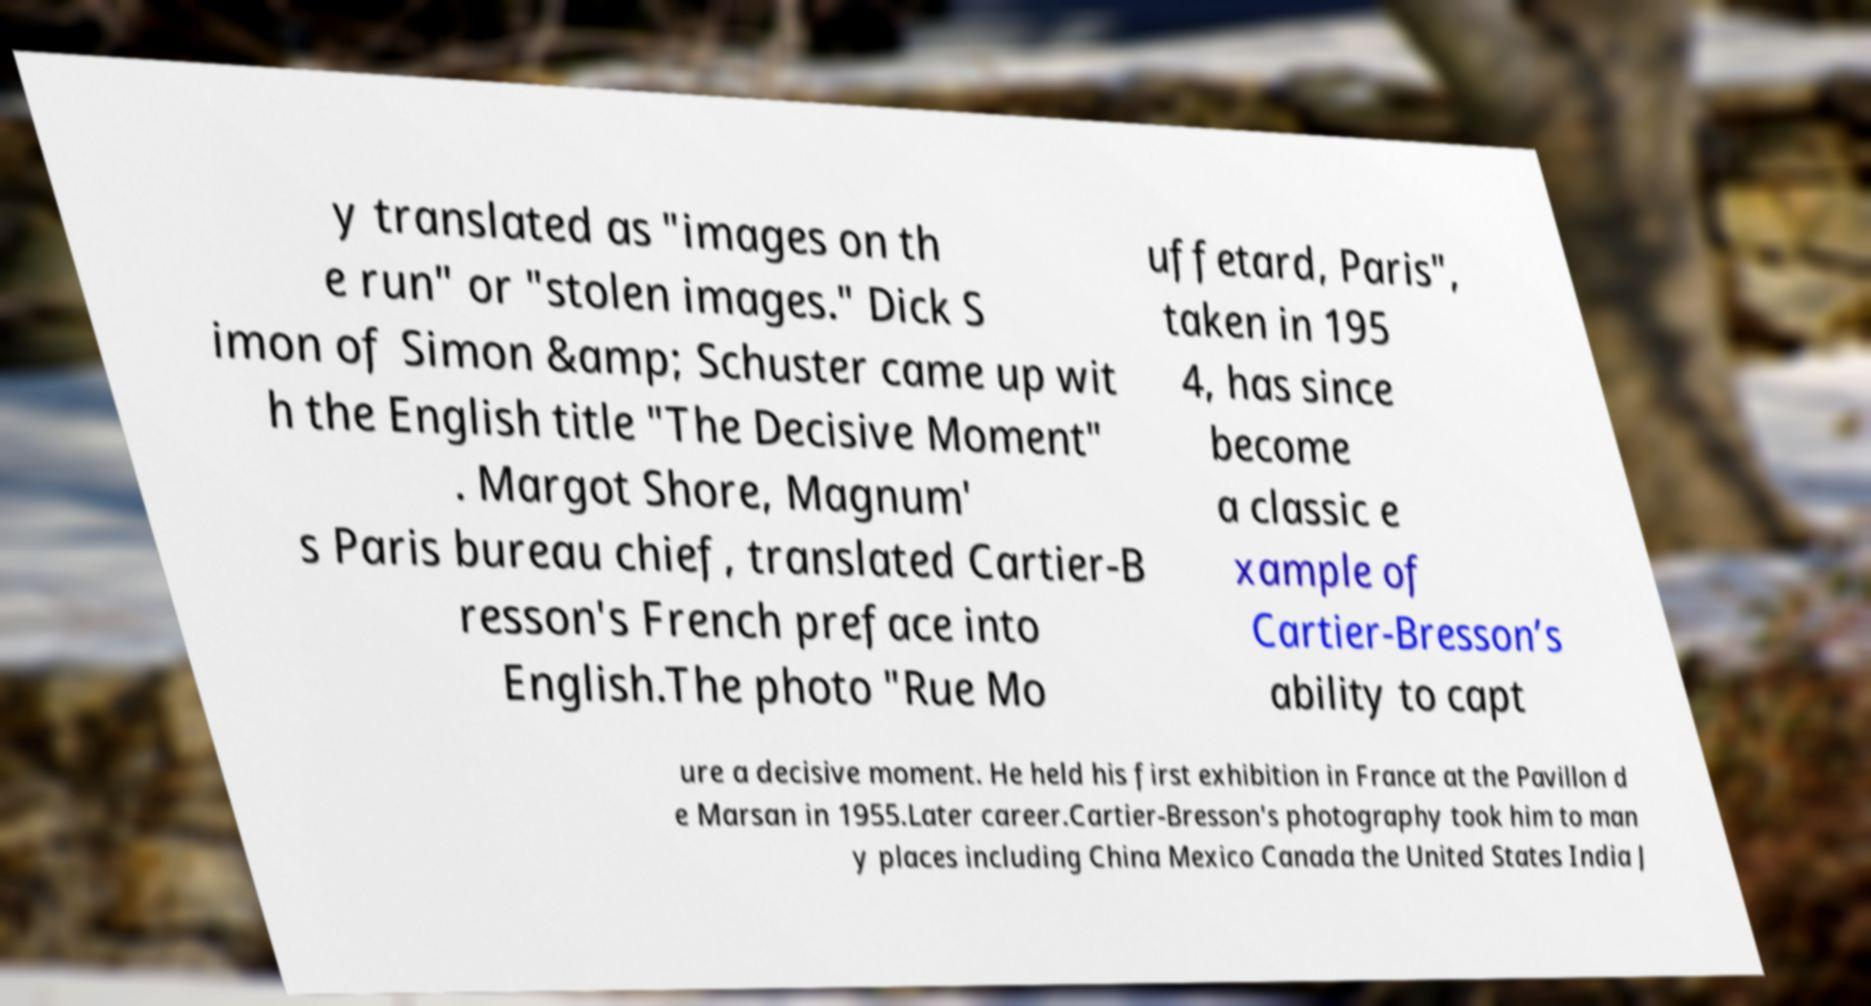What messages or text are displayed in this image? I need them in a readable, typed format. y translated as "images on th e run" or "stolen images." Dick S imon of Simon &amp; Schuster came up wit h the English title "The Decisive Moment" . Margot Shore, Magnum' s Paris bureau chief, translated Cartier-B resson's French preface into English.The photo "Rue Mo uffetard, Paris", taken in 195 4, has since become a classic e xample of Cartier-Bresson’s ability to capt ure a decisive moment. He held his first exhibition in France at the Pavillon d e Marsan in 1955.Later career.Cartier-Bresson's photography took him to man y places including China Mexico Canada the United States India J 